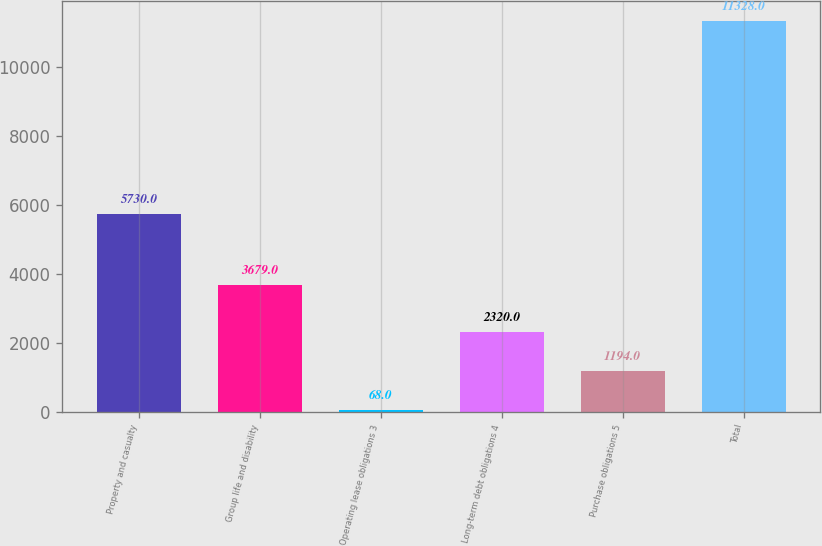<chart> <loc_0><loc_0><loc_500><loc_500><bar_chart><fcel>Property and casualty<fcel>Group life and disability<fcel>Operating lease obligations 3<fcel>Long-term debt obligations 4<fcel>Purchase obligations 5<fcel>Total<nl><fcel>5730<fcel>3679<fcel>68<fcel>2320<fcel>1194<fcel>11328<nl></chart> 